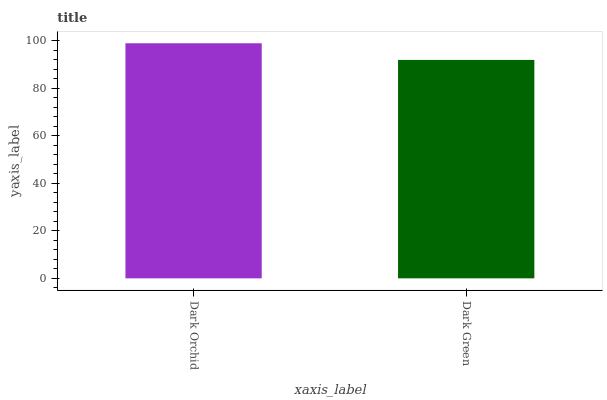Is Dark Green the minimum?
Answer yes or no. Yes. Is Dark Orchid the maximum?
Answer yes or no. Yes. Is Dark Green the maximum?
Answer yes or no. No. Is Dark Orchid greater than Dark Green?
Answer yes or no. Yes. Is Dark Green less than Dark Orchid?
Answer yes or no. Yes. Is Dark Green greater than Dark Orchid?
Answer yes or no. No. Is Dark Orchid less than Dark Green?
Answer yes or no. No. Is Dark Orchid the high median?
Answer yes or no. Yes. Is Dark Green the low median?
Answer yes or no. Yes. Is Dark Green the high median?
Answer yes or no. No. Is Dark Orchid the low median?
Answer yes or no. No. 